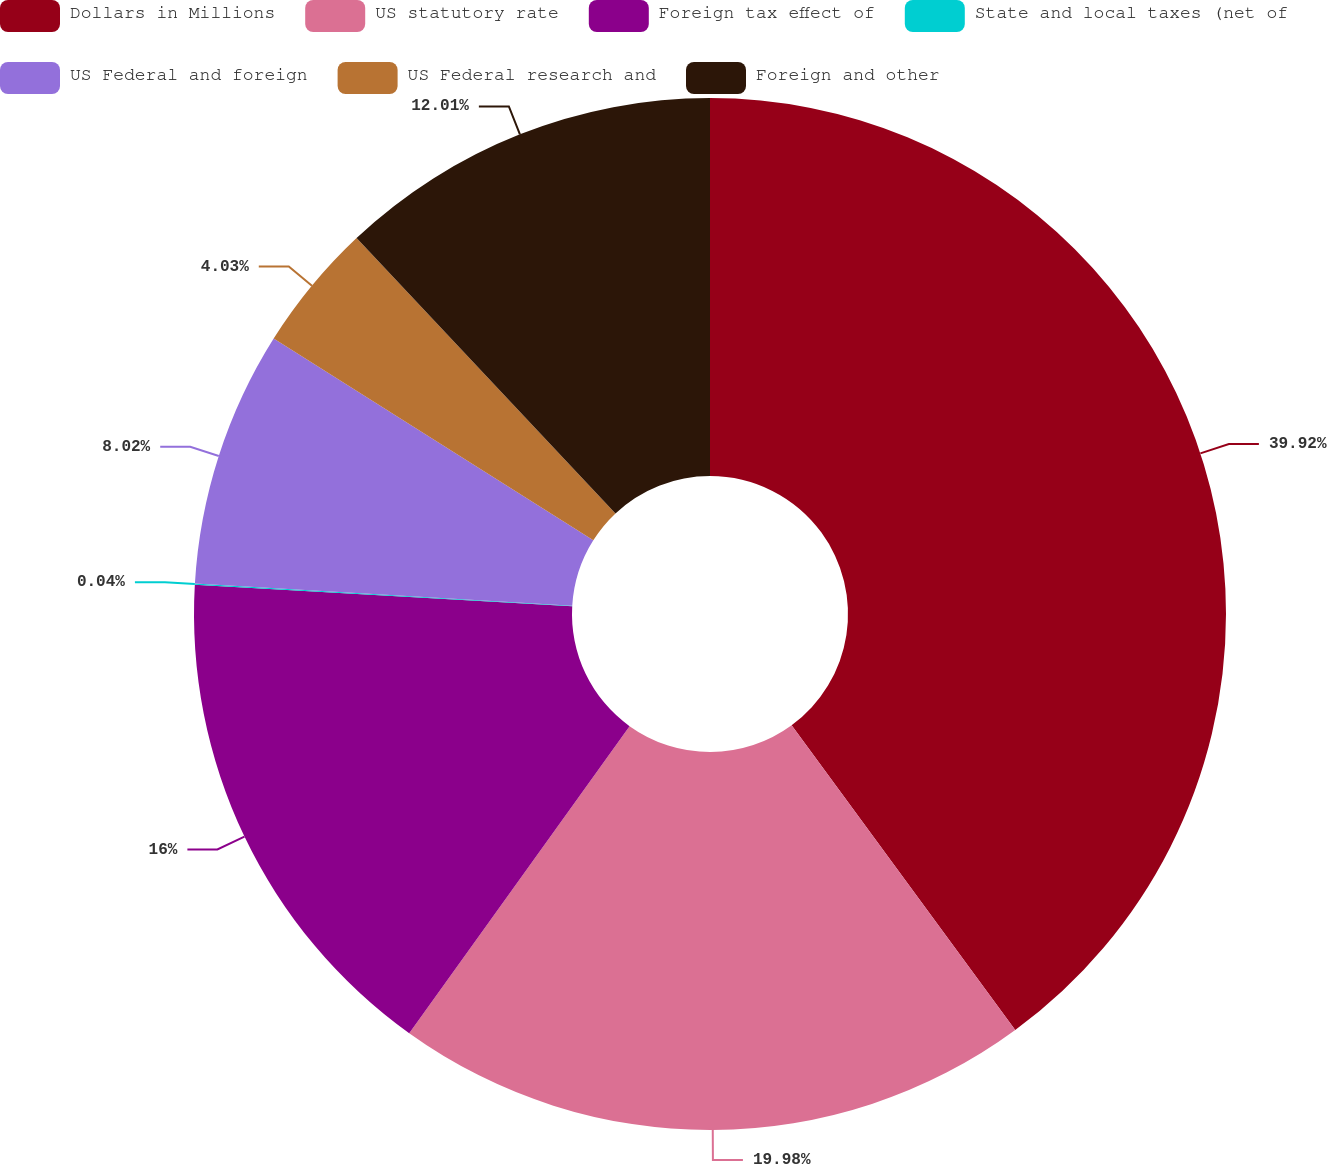<chart> <loc_0><loc_0><loc_500><loc_500><pie_chart><fcel>Dollars in Millions<fcel>US statutory rate<fcel>Foreign tax effect of<fcel>State and local taxes (net of<fcel>US Federal and foreign<fcel>US Federal research and<fcel>Foreign and other<nl><fcel>39.93%<fcel>19.98%<fcel>16.0%<fcel>0.04%<fcel>8.02%<fcel>4.03%<fcel>12.01%<nl></chart> 